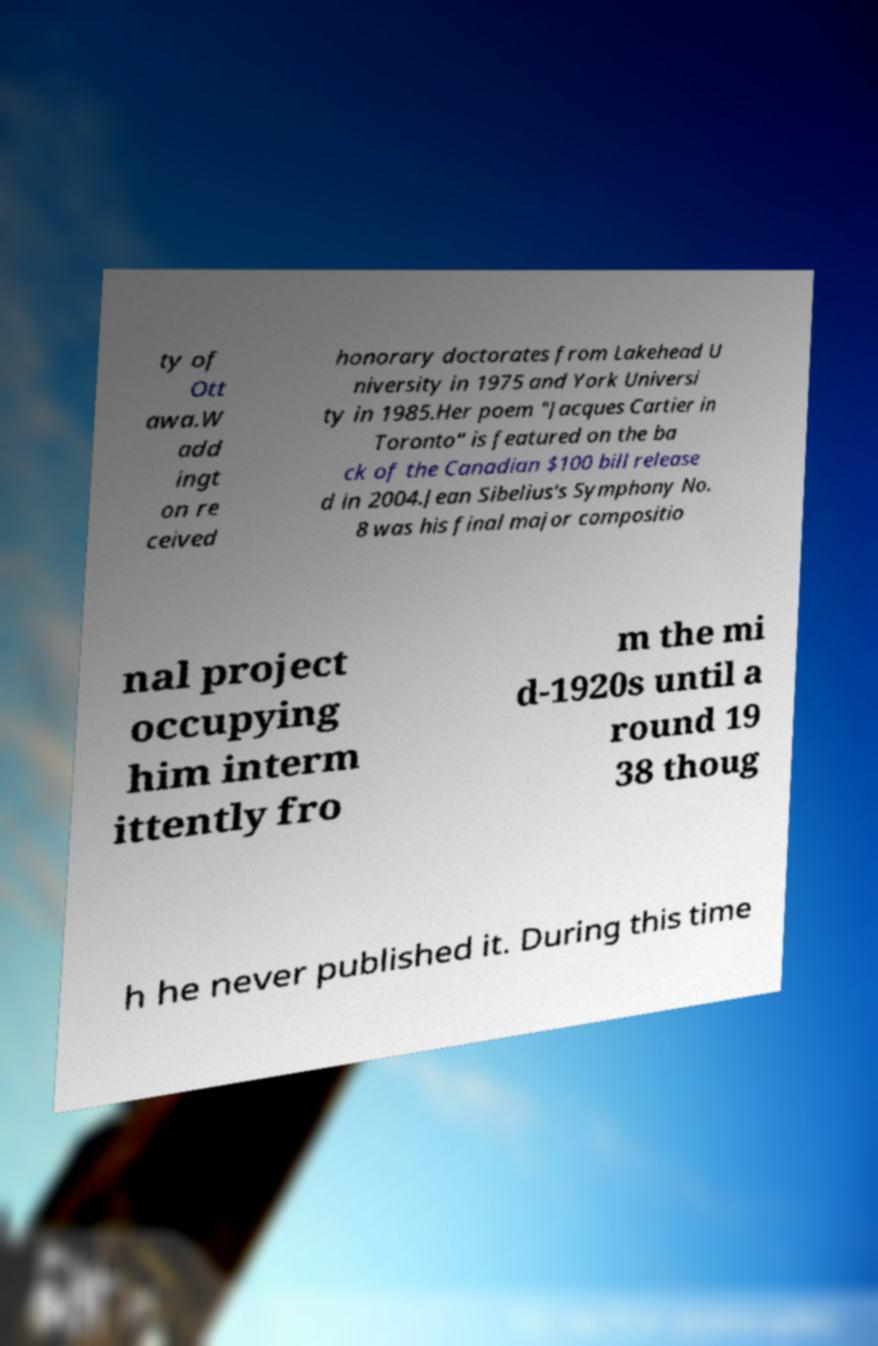Could you assist in decoding the text presented in this image and type it out clearly? ty of Ott awa.W add ingt on re ceived honorary doctorates from Lakehead U niversity in 1975 and York Universi ty in 1985.Her poem "Jacques Cartier in Toronto" is featured on the ba ck of the Canadian $100 bill release d in 2004.Jean Sibelius's Symphony No. 8 was his final major compositio nal project occupying him interm ittently fro m the mi d-1920s until a round 19 38 thoug h he never published it. During this time 